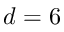Convert formula to latex. <formula><loc_0><loc_0><loc_500><loc_500>d = 6</formula> 